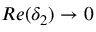Convert formula to latex. <formula><loc_0><loc_0><loc_500><loc_500>R e ( \delta _ { 2 } ) \rightarrow 0</formula> 